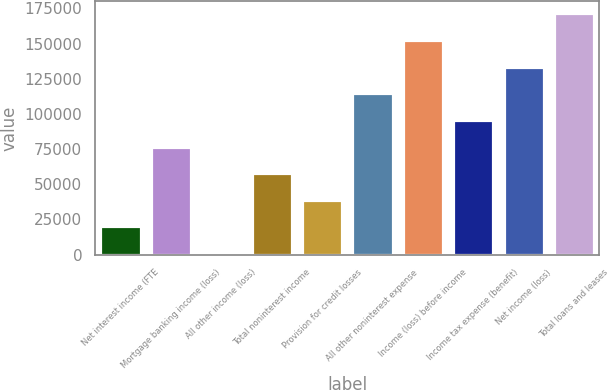Convert chart. <chart><loc_0><loc_0><loc_500><loc_500><bar_chart><fcel>Net interest income (FTE<fcel>Mortgage banking income (loss)<fcel>All other income (loss)<fcel>Total noninterest income<fcel>Provision for credit losses<fcel>All other noninterest expense<fcel>Income (loss) before income<fcel>Income tax expense (benefit)<fcel>Net income (loss)<fcel>Total loans and leases<nl><fcel>20010.5<fcel>76796<fcel>1082<fcel>57867.5<fcel>38939<fcel>114653<fcel>152510<fcel>95724.5<fcel>133582<fcel>171438<nl></chart> 